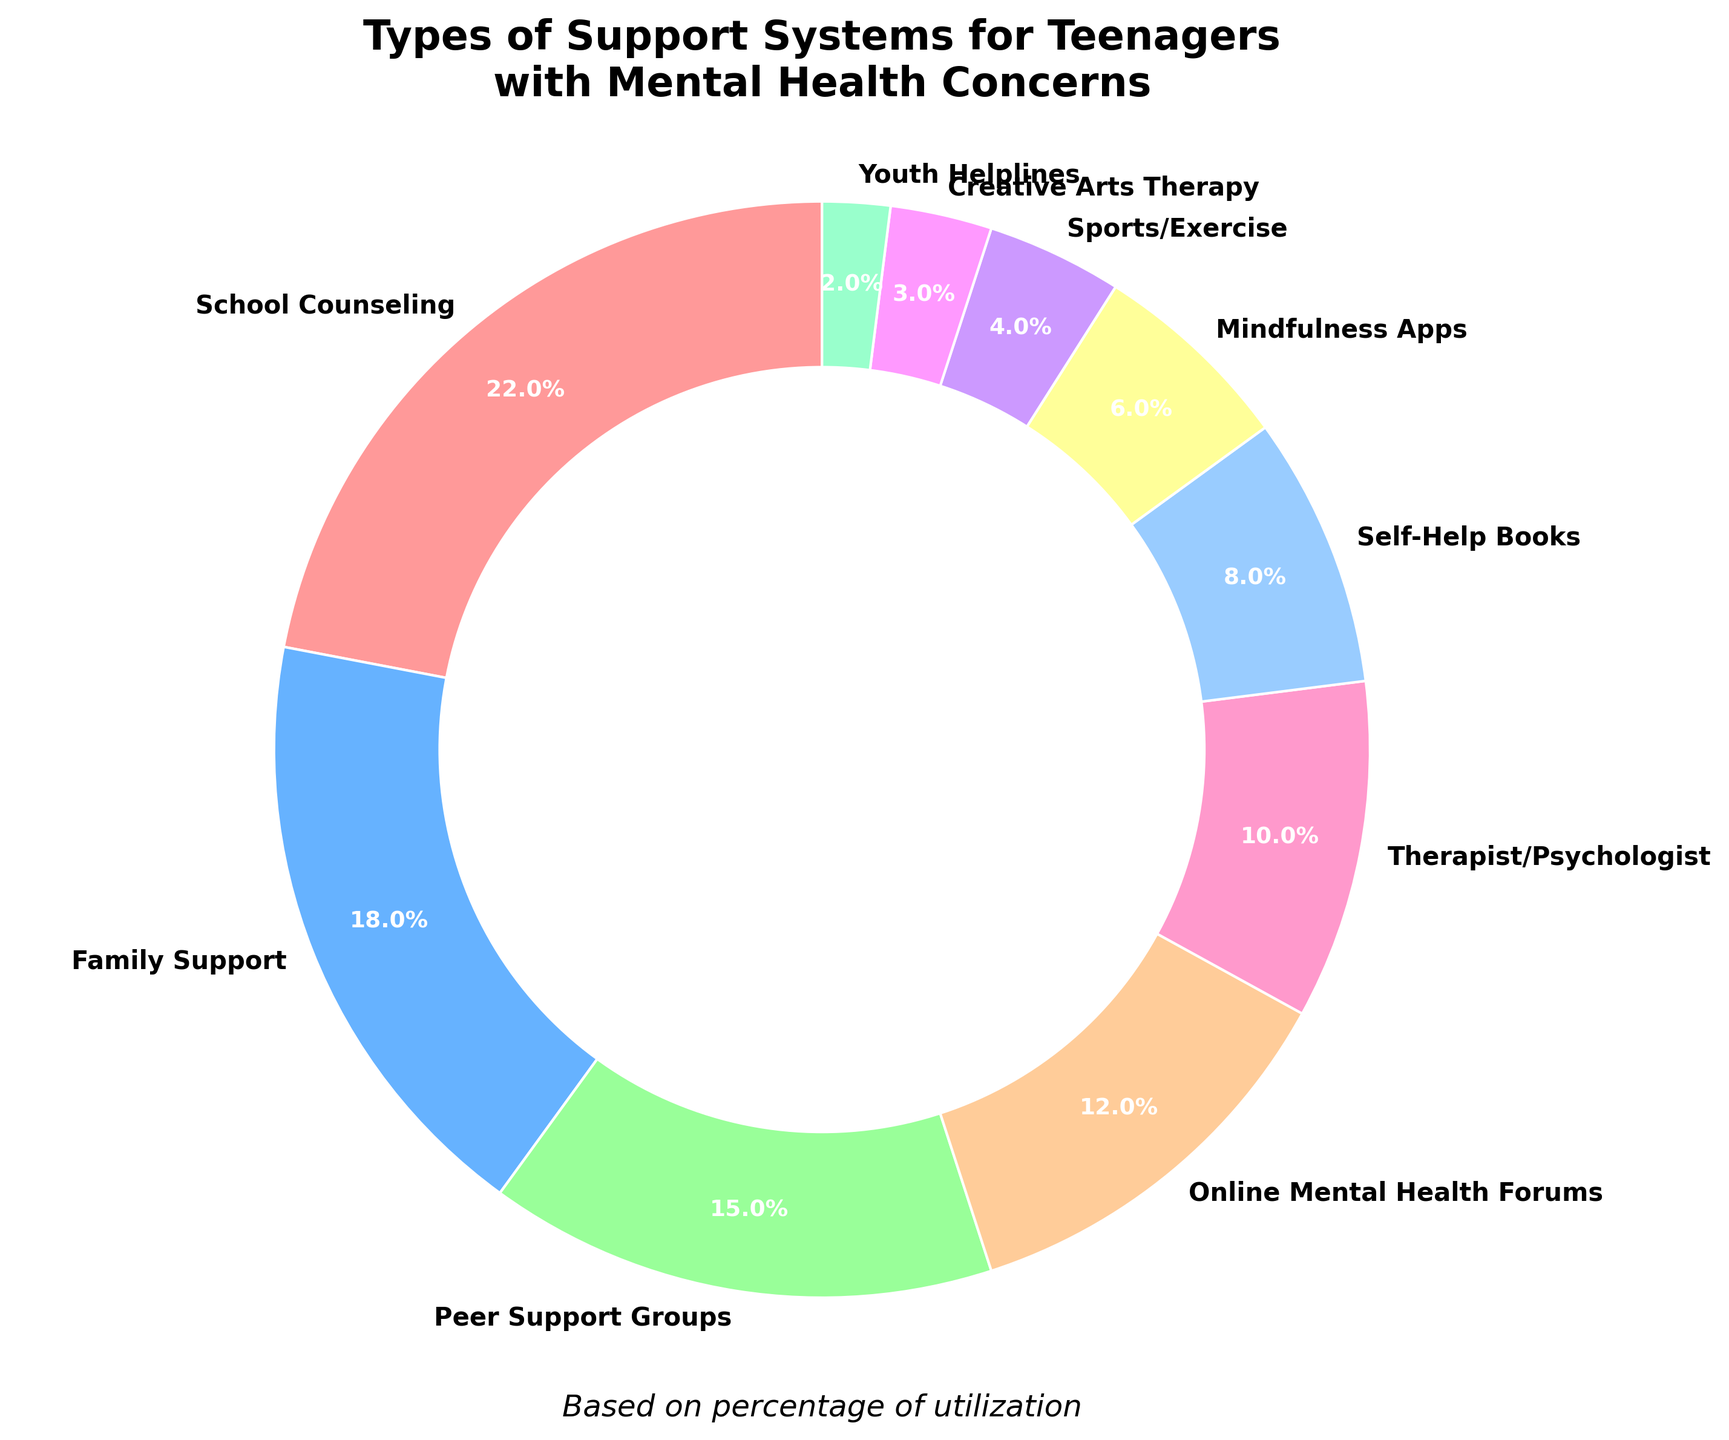What percentage of teenagers use family support compared to school counseling? School counseling is 22% and family support is 18%. To compare, we note that 22% is greater than 18%.
Answer: School counseling What's the total percentage of teenagers using both therapist/psychologist and creative arts therapy? Therapist/Psychologist is 10% and Creative Arts Therapy is 3%. Add these two values to get the total: 10% + 3% = 13%.
Answer: 13% Is the utilization of mindfulness apps higher or lower than self-help books? Mindfulness apps are utilized by 6% of teenagers, whereas self-help books are utilized by 8%. Since 6% is lower than 8%, mindfulness apps are utilized less.
Answer: Lower Which type of support system has the smallest percentage? The support type with the smallest wedge in the pie chart, representing the smallest percentage, is Youth Helplines at 2%.
Answer: Youth Helplines If you combine the usage percentages of sports/exercise, creative arts therapy, and youth helplines, what is the total? Sports/Exercise is 4%, Creative Arts Therapy is 3%, and Youth Helplines are 2%. Adding these together gives: 4% + 3% + 2% = 9%.
Answer: 9% What support system type is represented with the wedge that has a pink color shade? The pink wedge in the pie chart corresponds to School Counseling, which has a percentage of 22%.
Answer: School Counseling Among the types of support systems, which one ranks third in terms of usage percentage? The third-largest wedge in the pie chart is for Peer Support Groups at 15%, following School Counseling and Family Support.
Answer: Peer Support Groups How much higher is the percentage of online mental health forums compared to mindfulness apps? Online Mental Health Forums are at 12%, while Mindfulness Apps are at 6%. Subtract the smaller percentage from the larger one: 12% - 6% = 6%.
Answer: 6% What is the combined percentage usage of the top three support systems? The top three support systems are School Counseling (22%), Family Support (18%), and Peer Support Groups (15%). Adding these percentages together: 22% + 18% + 15% = 55%.
Answer: 55% What support system type is represented by the smallest visible wedge on the pie chart? The smallest visible wedge on the pie chart, with a percentage of 2%, is Youth Helplines.
Answer: Youth Helplines 